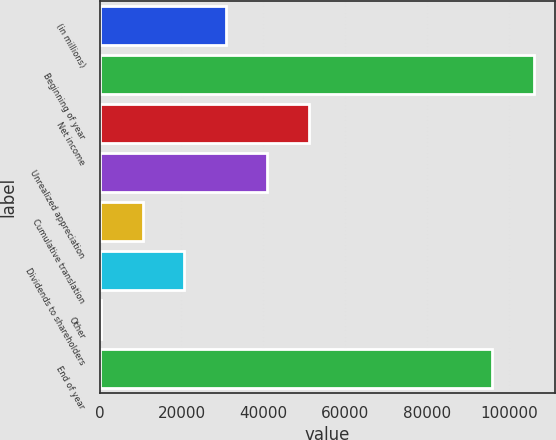Convert chart. <chart><loc_0><loc_0><loc_500><loc_500><bar_chart><fcel>(in millions)<fcel>Beginning of year<fcel>Net income<fcel>Unrealized appreciation<fcel>Cumulative translation<fcel>Dividends to shareholders<fcel>Other<fcel>End of year<nl><fcel>30802<fcel>105926<fcel>51052<fcel>40927<fcel>10552<fcel>20677<fcel>427<fcel>95801<nl></chart> 